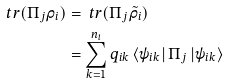<formula> <loc_0><loc_0><loc_500><loc_500>\ t r ( \Pi _ { j } \rho _ { i } ) & = \ t r ( \Pi _ { j } \tilde { \rho } _ { i } ) \\ & = \sum _ { k = 1 } ^ { n _ { i } } q _ { i k } \left \langle \psi _ { i k } \right | \Pi _ { j } \left | \psi _ { i k } \right \rangle</formula> 